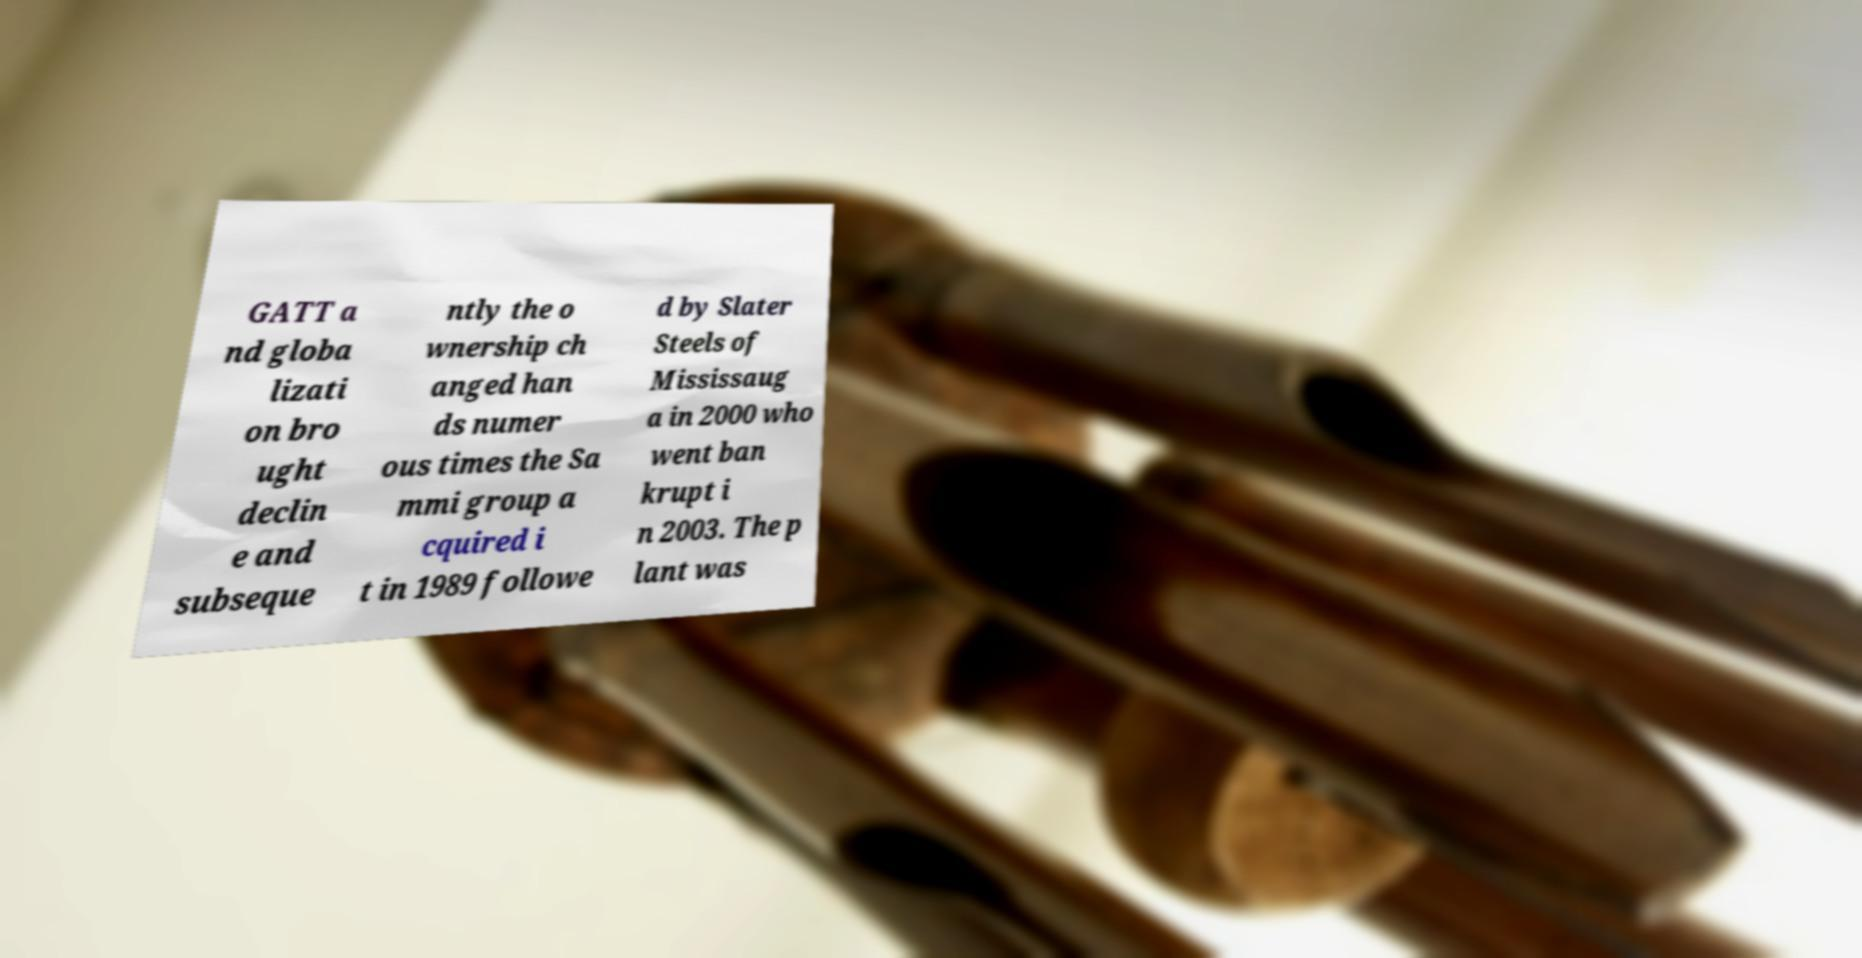For documentation purposes, I need the text within this image transcribed. Could you provide that? GATT a nd globa lizati on bro ught declin e and subseque ntly the o wnership ch anged han ds numer ous times the Sa mmi group a cquired i t in 1989 followe d by Slater Steels of Mississaug a in 2000 who went ban krupt i n 2003. The p lant was 